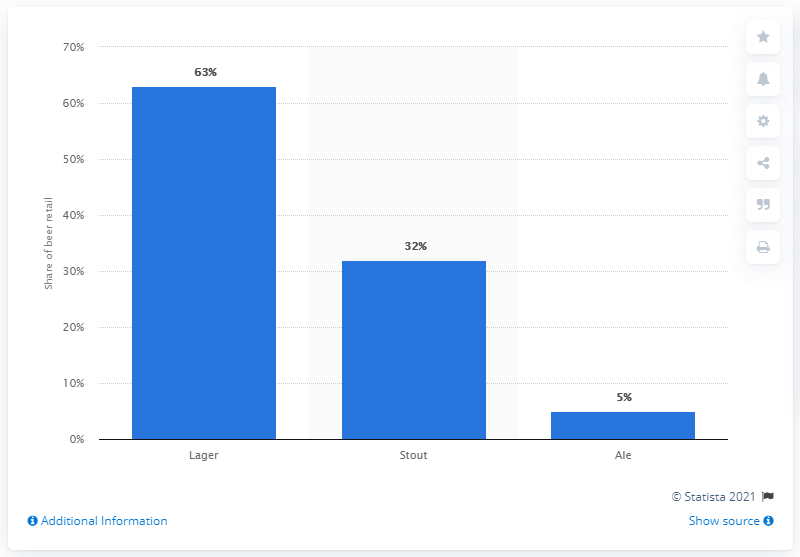Identify some key points in this picture. According to recent data, the most popular type of beer in Ireland is lager. 